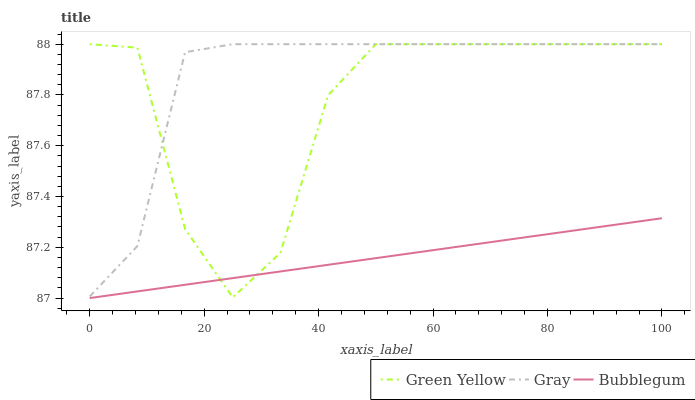Does Green Yellow have the minimum area under the curve?
Answer yes or no. No. Does Green Yellow have the maximum area under the curve?
Answer yes or no. No. Is Green Yellow the smoothest?
Answer yes or no. No. Is Bubblegum the roughest?
Answer yes or no. No. Does Green Yellow have the lowest value?
Answer yes or no. No. Does Bubblegum have the highest value?
Answer yes or no. No. Is Bubblegum less than Gray?
Answer yes or no. Yes. Is Gray greater than Bubblegum?
Answer yes or no. Yes. Does Bubblegum intersect Gray?
Answer yes or no. No. 